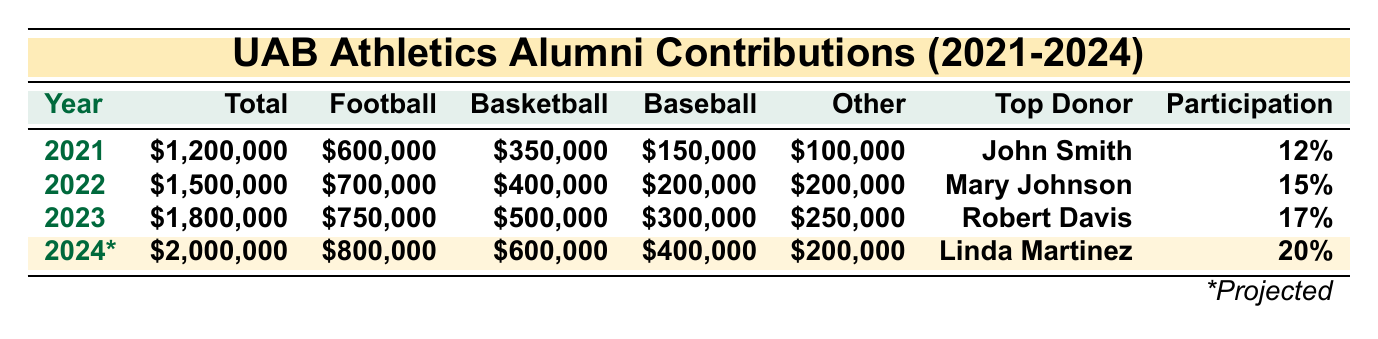What is the total alumni contribution for the year 2022? The total contribution for 2022 is provided directly in the table under the "Total" column for that year, which states $1,500,000.
Answer: $1,500,000 Who was the top alumni donor in 2023? The top donor for 2023 can be found in the "Top Donor" column for that year, where it lists Robert Davis.
Answer: Robert Davis What is the projected contribution for basketball in 2024? The projected contribution for basketball in 2024 is located in the "ProjectedBasketball" column, which indicates $600,000.
Answer: $600,000 How much more was contributed to football in 2023 compared to 2021? To find the difference, subtract the football contributions for 2021 ($600,000) from 2023 ($750,000). This gives $750,000 - $600,000 = $150,000.
Answer: $150,000 What is the percentage increase in total contributions from 2021 to 2023? First, calculate the contributions for both years: $1,200,000 (2021) and $1,800,000 (2023). The increase is $1,800,000 - $1,200,000 = $600,000. To find the percentage increase, use the formula (increase/original) * 100: ($600,000 / $1,200,000) * 100 = 50%.
Answer: 50% Did the total contributions increase each year from 2021 to 2023? By examining the "Total" column, each subsequent year shows a higher total: $1,200,000 in 2021, $1,500,000 in 2022, and $1,800,000 in 2023, indicating a yes.
Answer: Yes What is the average alumni participation rate from 2021 to 2023? The participation rates for each year are 12%, 15%, and 17%. To find the average: (12 + 15 + 17) / 3 = 44 / 3 = 14.67%.
Answer: 14.67% How much did alumni contribute to baseball in 2024 compared to 2023? Contributions to baseball in 2023 were $300,000, whereas projections for 2024 indicate $400,000. The difference is $400,000 - $300,000 = $100,000.
Answer: $100,000 What was the total amount contributed to sports other than football and basketball in 2022? Total contributions to other sports in 2022 can be found by adding the contributions for baseball and other sports, which are $200,000 and $200,000 respectively, giving a total of $400,000.
Answer: $400,000 What is the ratio of basketball to football contributions in 2021? The contributions for basketball in 2021 are $350,000, and for football, they are $600,000. The ratio is $350,000:$600,000, which simplifies to 7:12.
Answer: 7:12 Is the major gift in 2022 greater than in 2021? The major gift for 2022 is $300,000, and for 2021, it is $250,000. Since $300,000 is more than $250,000, the answer is yes.
Answer: Yes 